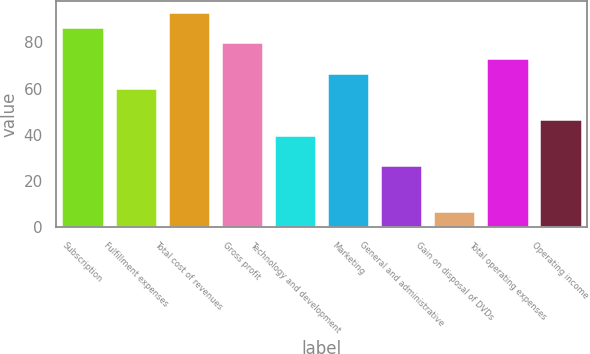Convert chart. <chart><loc_0><loc_0><loc_500><loc_500><bar_chart><fcel>Subscription<fcel>Fulfillment expenses<fcel>Total cost of revenues<fcel>Gross profit<fcel>Technology and development<fcel>Marketing<fcel>General and administrative<fcel>Gain on disposal of DVDs<fcel>Total operating expenses<fcel>Operating income<nl><fcel>86.65<fcel>60.05<fcel>93.3<fcel>80<fcel>40.1<fcel>66.7<fcel>26.8<fcel>6.85<fcel>73.35<fcel>46.75<nl></chart> 